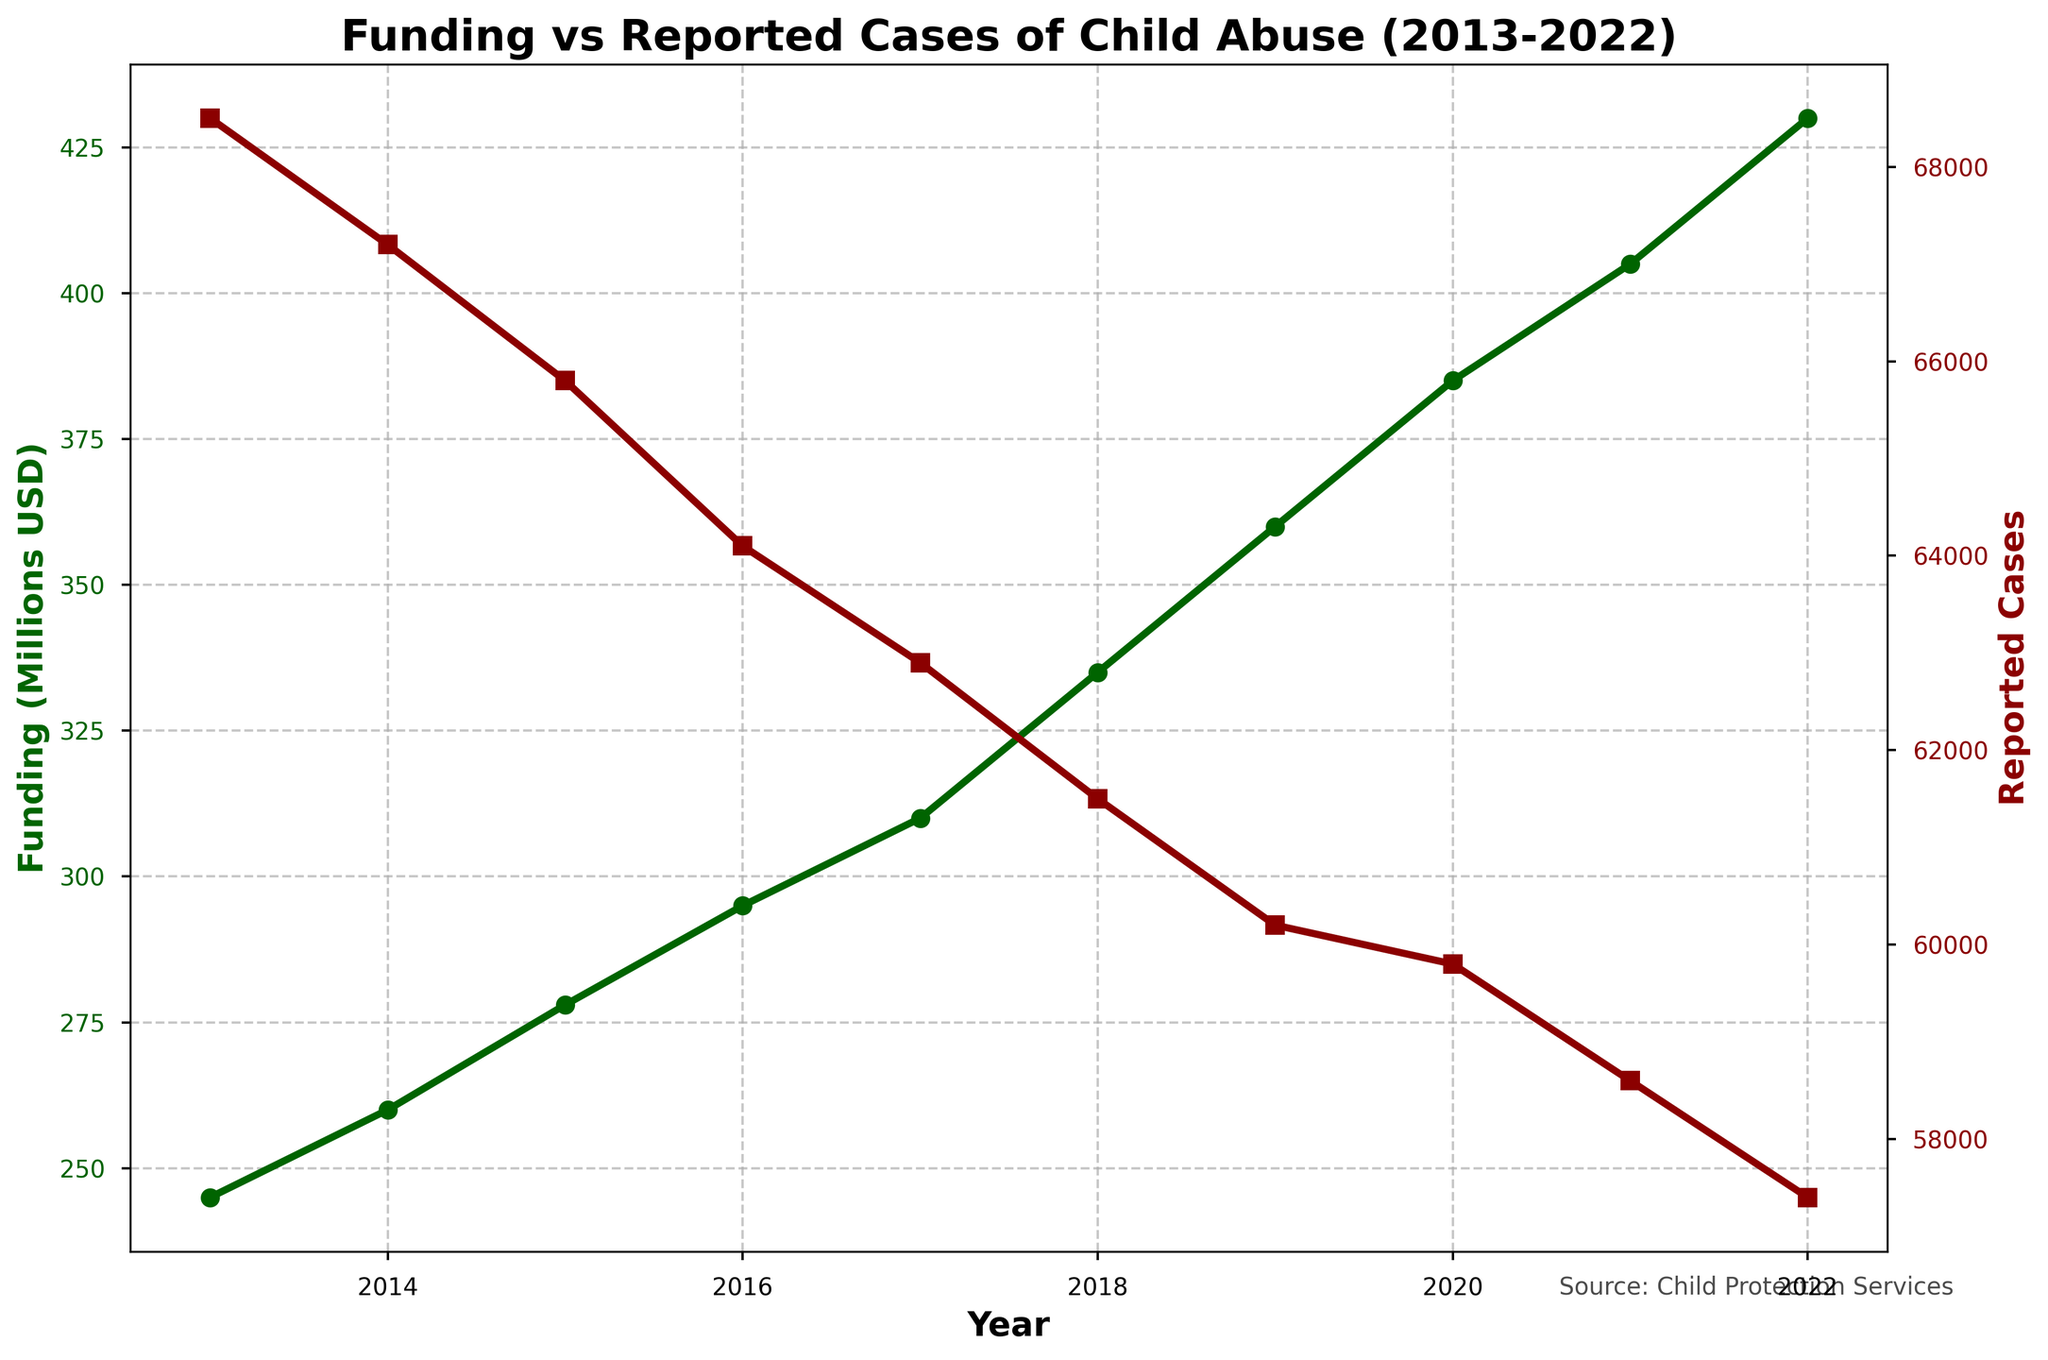What is the general trend in the funding allocated to child abuse prevention programs from 2013 to 2022? The funding allocated to child abuse prevention programs shows a consistent increase over the years from 2013 to 2022. In 2013, the funding was at 245 million USD, and by 2022, it rose steadily to 430 million USD.
Answer: It is increasing How has the number of reported cases of child abuse changed over the last decade? The number of reported cases of child abuse has shown a steady decrease over the decade. It started at 68,500 in 2013 and has decreased each subsequent year, reaching 57,400 in 2022.
Answer: It is decreasing Compare the funding between the year with the highest funding and the lowest funding. What is the difference? The highest funding is 430 million USD in 2022, and the lowest funding is 245 million USD in 2013. The difference between the highest and lowest funding is calculated as 430 - 245 = 185 million USD.
Answer: 185 million USD What is the average funding allocated to child abuse prevention programs from 2013 to 2022? To find the average, sum all the annual funding values from 2013 to 2022 and divide by the number of years. [(245 + 260 + 278 + 295 + 310 + 335 + 360 + 385 + 405 + 430) / 10] = (3303 / 10) = 330.3 million USD
Answer: 330.3 million USD Compare the reported cases in 2017 and 2020. Which year had fewer reported cases, and by how much? The reported cases in 2017 were 62,900, while in 2020, there were 59,800 reported cases. To find the difference, subtract the number of cases in 2020 from 2017: 62,900 - 59,800 = 3,100. Thus, 2020 had 3,100 fewer reported cases than 2017.
Answer: 2020, by 3,100 cases What can be inferred about the relationship between increased funding and reported cases of child abuse? As funding increased from 245 million USD in 2013 to 430 million USD in 2022, the reported cases of child abuse decreased from 68,500 to 57,400. This suggests a possible inverse relationship, where higher funding might contribute to fewer reported cases.
Answer: Higher funding appears to correlate with fewer cases Between which consecutive years was the largest increase in funding observed? To find the largest increase, calculate the difference in funding for each consecutive year and compare them. The differences are: 2013-2014 (15), 2014-2015 (18), 2015-2016 (17), 2016-2017 (15), 2017-2018 (25), 2018-2019 (25), 2019-2020 (25), 2020-2021 (20), 2021-2022 (25). The largest increase of 25 million USD occurred between 2017-2018, 2018-2019, 2019-2020, and 2021-2022.
Answer: 2017-2018, 2018-2019, 2019-2020, 2021-2022 How did reported cases of child abuse change during the years when funding increased by the largest amount? During the years when funding increased by the largest amount (2017-2018, 2018-2019, 2019-2020, and 2021-2022), reported cases decreased consistently. From 2018 to 2019, cases dropped from 61,500 to 60,200, and by 2022, reached 57,400.
Answer: Reported cases decreased What was the funding allocated in the last year with the highest number of reported cases? The highest number of reported cases in the dataset is 68,500 in 2013. The funding allocated in that year was 245 million USD.
Answer: 245 million USD 